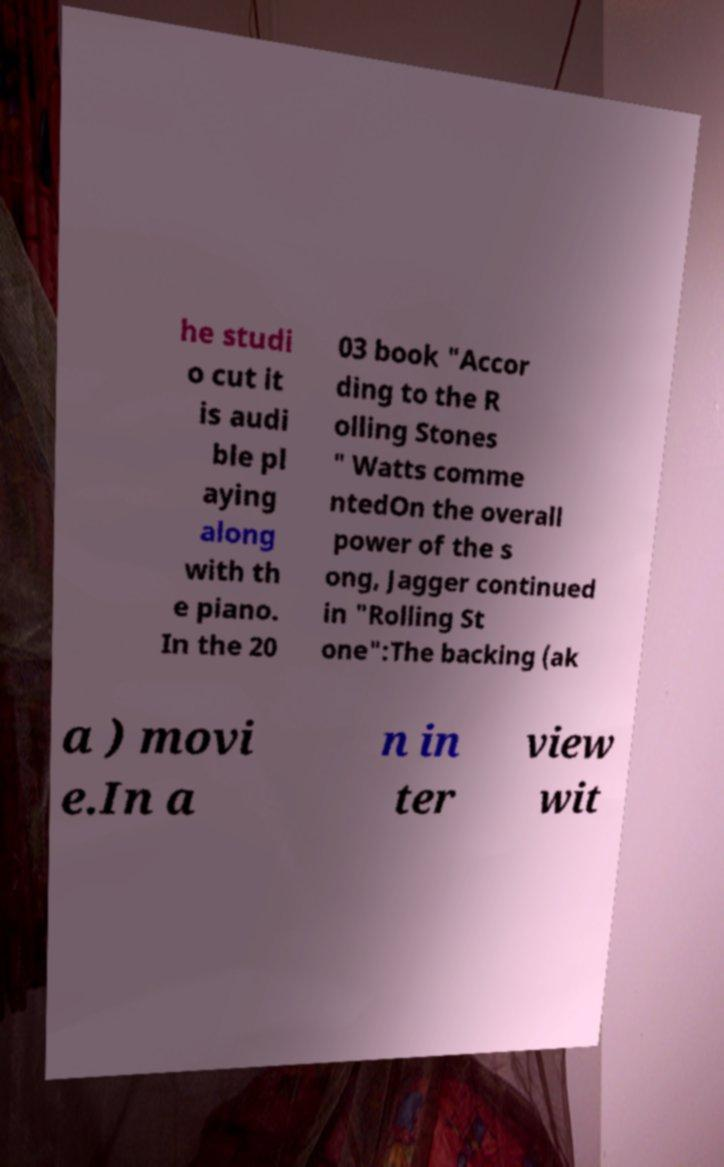There's text embedded in this image that I need extracted. Can you transcribe it verbatim? he studi o cut it is audi ble pl aying along with th e piano. In the 20 03 book "Accor ding to the R olling Stones " Watts comme ntedOn the overall power of the s ong, Jagger continued in "Rolling St one":The backing (ak a ) movi e.In a n in ter view wit 